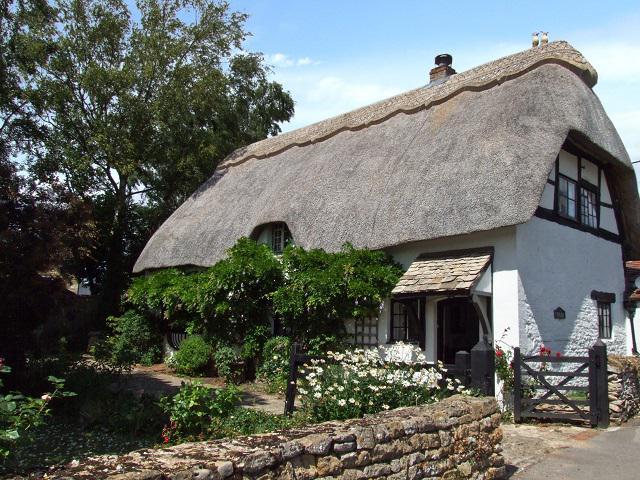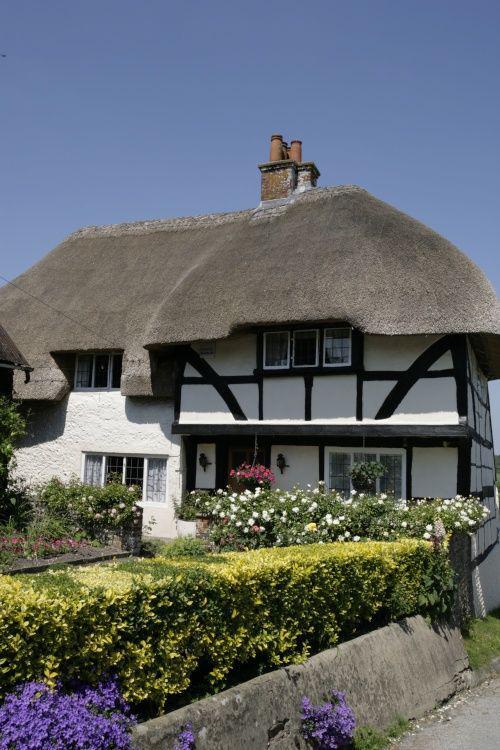The first image is the image on the left, the second image is the image on the right. Evaluate the accuracy of this statement regarding the images: "All the houses have chimneys.". Is it true? Answer yes or no. Yes. The first image is the image on the left, the second image is the image on the right. Examine the images to the left and right. Is the description "At least one image shows the front of a white house with scallop trim along the top of the peaked roof, at least one notch in the roof line, and a separate roof over the front door." accurate? Answer yes or no. Yes. 